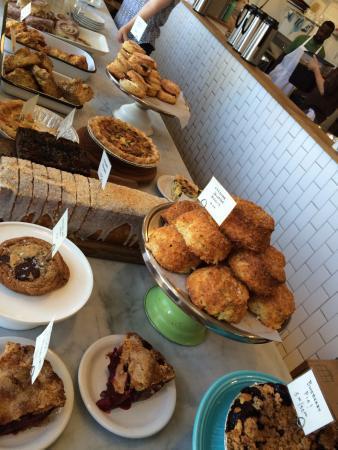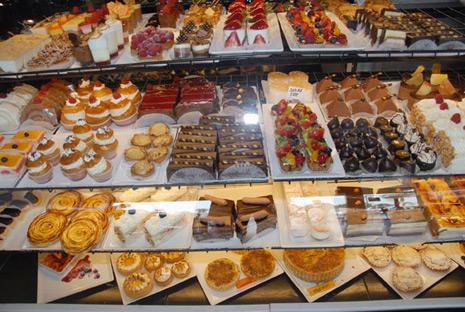The first image is the image on the left, the second image is the image on the right. Given the left and right images, does the statement "There is a single green cake holder that contains  at least seven yellow and brown looking muffin tops." hold true? Answer yes or no. Yes. The first image is the image on the left, the second image is the image on the right. Given the left and right images, does the statement "Each image contains a person behind a counter." hold true? Answer yes or no. No. 